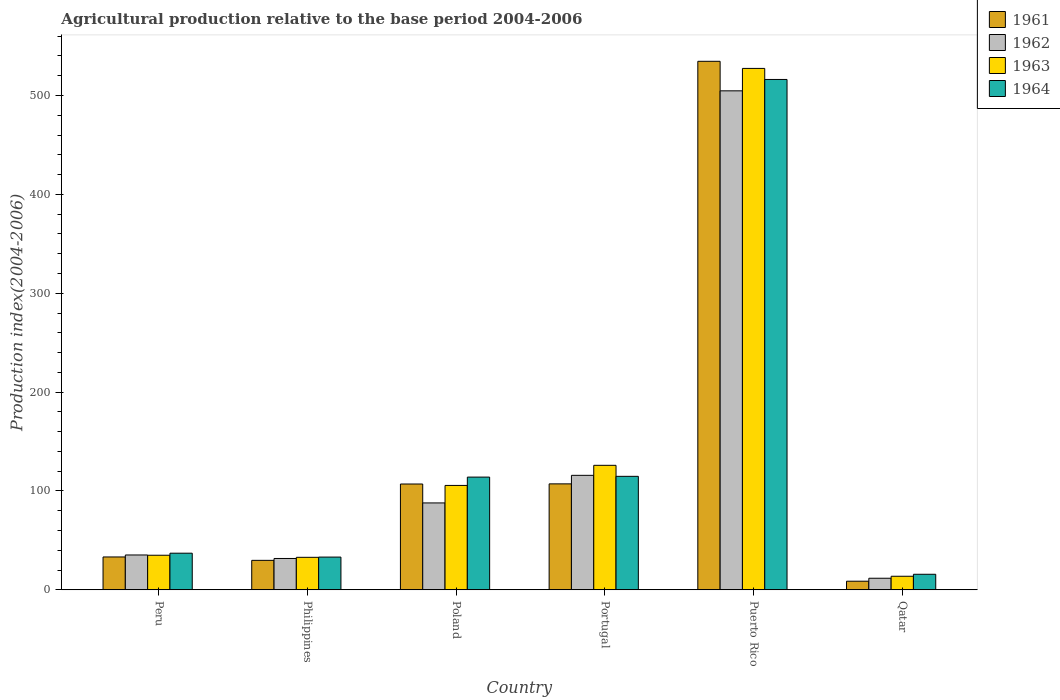How many different coloured bars are there?
Your answer should be very brief. 4. Are the number of bars per tick equal to the number of legend labels?
Offer a very short reply. Yes. Are the number of bars on each tick of the X-axis equal?
Your answer should be very brief. Yes. How many bars are there on the 3rd tick from the left?
Give a very brief answer. 4. How many bars are there on the 1st tick from the right?
Your answer should be very brief. 4. What is the label of the 4th group of bars from the left?
Offer a very short reply. Portugal. In how many cases, is the number of bars for a given country not equal to the number of legend labels?
Keep it short and to the point. 0. What is the agricultural production index in 1961 in Puerto Rico?
Your answer should be very brief. 534.58. Across all countries, what is the maximum agricultural production index in 1963?
Keep it short and to the point. 527.38. Across all countries, what is the minimum agricultural production index in 1964?
Your answer should be very brief. 15.74. In which country was the agricultural production index in 1962 maximum?
Offer a terse response. Puerto Rico. In which country was the agricultural production index in 1963 minimum?
Offer a terse response. Qatar. What is the total agricultural production index in 1962 in the graph?
Your response must be concise. 787.16. What is the difference between the agricultural production index in 1962 in Poland and that in Qatar?
Your answer should be compact. 76.17. What is the difference between the agricultural production index in 1964 in Qatar and the agricultural production index in 1963 in Peru?
Your response must be concise. -19.25. What is the average agricultural production index in 1964 per country?
Your response must be concise. 138.5. What is the difference between the agricultural production index of/in 1963 and agricultural production index of/in 1964 in Philippines?
Your answer should be compact. -0.24. In how many countries, is the agricultural production index in 1963 greater than 340?
Offer a very short reply. 1. What is the ratio of the agricultural production index in 1961 in Puerto Rico to that in Qatar?
Provide a succinct answer. 61.23. Is the agricultural production index in 1963 in Peru less than that in Puerto Rico?
Your answer should be very brief. Yes. Is the difference between the agricultural production index in 1963 in Peru and Poland greater than the difference between the agricultural production index in 1964 in Peru and Poland?
Your answer should be compact. Yes. What is the difference between the highest and the second highest agricultural production index in 1963?
Provide a succinct answer. -20.34. What is the difference between the highest and the lowest agricultural production index in 1961?
Offer a terse response. 525.85. In how many countries, is the agricultural production index in 1962 greater than the average agricultural production index in 1962 taken over all countries?
Offer a very short reply. 1. Is the sum of the agricultural production index in 1963 in Peru and Philippines greater than the maximum agricultural production index in 1964 across all countries?
Offer a very short reply. No. Is it the case that in every country, the sum of the agricultural production index in 1963 and agricultural production index in 1962 is greater than the sum of agricultural production index in 1964 and agricultural production index in 1961?
Give a very brief answer. No. What does the 3rd bar from the right in Qatar represents?
Your answer should be very brief. 1962. Is it the case that in every country, the sum of the agricultural production index in 1963 and agricultural production index in 1964 is greater than the agricultural production index in 1962?
Offer a terse response. Yes. How many bars are there?
Provide a short and direct response. 24. How many countries are there in the graph?
Provide a short and direct response. 6. Does the graph contain grids?
Provide a succinct answer. No. How many legend labels are there?
Offer a terse response. 4. What is the title of the graph?
Keep it short and to the point. Agricultural production relative to the base period 2004-2006. What is the label or title of the Y-axis?
Provide a short and direct response. Production index(2004-2006). What is the Production index(2004-2006) in 1961 in Peru?
Your answer should be compact. 33.26. What is the Production index(2004-2006) of 1962 in Peru?
Give a very brief answer. 35.27. What is the Production index(2004-2006) of 1963 in Peru?
Offer a terse response. 34.99. What is the Production index(2004-2006) in 1964 in Peru?
Offer a terse response. 37.07. What is the Production index(2004-2006) of 1961 in Philippines?
Offer a very short reply. 29.83. What is the Production index(2004-2006) in 1962 in Philippines?
Offer a terse response. 31.73. What is the Production index(2004-2006) of 1963 in Philippines?
Keep it short and to the point. 32.89. What is the Production index(2004-2006) in 1964 in Philippines?
Your response must be concise. 33.13. What is the Production index(2004-2006) in 1961 in Poland?
Ensure brevity in your answer.  107.05. What is the Production index(2004-2006) of 1962 in Poland?
Your response must be concise. 87.9. What is the Production index(2004-2006) in 1963 in Poland?
Keep it short and to the point. 105.61. What is the Production index(2004-2006) of 1964 in Poland?
Ensure brevity in your answer.  114.03. What is the Production index(2004-2006) of 1961 in Portugal?
Ensure brevity in your answer.  107.18. What is the Production index(2004-2006) of 1962 in Portugal?
Your answer should be very brief. 115.82. What is the Production index(2004-2006) of 1963 in Portugal?
Your response must be concise. 125.95. What is the Production index(2004-2006) in 1964 in Portugal?
Your response must be concise. 114.81. What is the Production index(2004-2006) in 1961 in Puerto Rico?
Keep it short and to the point. 534.58. What is the Production index(2004-2006) of 1962 in Puerto Rico?
Keep it short and to the point. 504.71. What is the Production index(2004-2006) in 1963 in Puerto Rico?
Provide a short and direct response. 527.38. What is the Production index(2004-2006) of 1964 in Puerto Rico?
Offer a very short reply. 516.21. What is the Production index(2004-2006) in 1961 in Qatar?
Ensure brevity in your answer.  8.73. What is the Production index(2004-2006) in 1962 in Qatar?
Your response must be concise. 11.73. What is the Production index(2004-2006) in 1963 in Qatar?
Your response must be concise. 13.74. What is the Production index(2004-2006) in 1964 in Qatar?
Your response must be concise. 15.74. Across all countries, what is the maximum Production index(2004-2006) in 1961?
Ensure brevity in your answer.  534.58. Across all countries, what is the maximum Production index(2004-2006) in 1962?
Provide a succinct answer. 504.71. Across all countries, what is the maximum Production index(2004-2006) in 1963?
Your answer should be compact. 527.38. Across all countries, what is the maximum Production index(2004-2006) in 1964?
Give a very brief answer. 516.21. Across all countries, what is the minimum Production index(2004-2006) of 1961?
Provide a succinct answer. 8.73. Across all countries, what is the minimum Production index(2004-2006) of 1962?
Give a very brief answer. 11.73. Across all countries, what is the minimum Production index(2004-2006) in 1963?
Your answer should be compact. 13.74. Across all countries, what is the minimum Production index(2004-2006) of 1964?
Your answer should be very brief. 15.74. What is the total Production index(2004-2006) in 1961 in the graph?
Offer a terse response. 820.63. What is the total Production index(2004-2006) in 1962 in the graph?
Offer a terse response. 787.16. What is the total Production index(2004-2006) in 1963 in the graph?
Your answer should be very brief. 840.56. What is the total Production index(2004-2006) in 1964 in the graph?
Your answer should be very brief. 830.99. What is the difference between the Production index(2004-2006) of 1961 in Peru and that in Philippines?
Keep it short and to the point. 3.43. What is the difference between the Production index(2004-2006) in 1962 in Peru and that in Philippines?
Offer a terse response. 3.54. What is the difference between the Production index(2004-2006) in 1963 in Peru and that in Philippines?
Make the answer very short. 2.1. What is the difference between the Production index(2004-2006) of 1964 in Peru and that in Philippines?
Your answer should be compact. 3.94. What is the difference between the Production index(2004-2006) of 1961 in Peru and that in Poland?
Give a very brief answer. -73.79. What is the difference between the Production index(2004-2006) in 1962 in Peru and that in Poland?
Offer a terse response. -52.63. What is the difference between the Production index(2004-2006) in 1963 in Peru and that in Poland?
Offer a very short reply. -70.62. What is the difference between the Production index(2004-2006) of 1964 in Peru and that in Poland?
Your answer should be compact. -76.96. What is the difference between the Production index(2004-2006) in 1961 in Peru and that in Portugal?
Offer a very short reply. -73.92. What is the difference between the Production index(2004-2006) in 1962 in Peru and that in Portugal?
Give a very brief answer. -80.55. What is the difference between the Production index(2004-2006) of 1963 in Peru and that in Portugal?
Provide a short and direct response. -90.96. What is the difference between the Production index(2004-2006) of 1964 in Peru and that in Portugal?
Your answer should be very brief. -77.74. What is the difference between the Production index(2004-2006) in 1961 in Peru and that in Puerto Rico?
Ensure brevity in your answer.  -501.32. What is the difference between the Production index(2004-2006) of 1962 in Peru and that in Puerto Rico?
Provide a succinct answer. -469.44. What is the difference between the Production index(2004-2006) of 1963 in Peru and that in Puerto Rico?
Your response must be concise. -492.39. What is the difference between the Production index(2004-2006) of 1964 in Peru and that in Puerto Rico?
Your response must be concise. -479.14. What is the difference between the Production index(2004-2006) in 1961 in Peru and that in Qatar?
Provide a short and direct response. 24.53. What is the difference between the Production index(2004-2006) in 1962 in Peru and that in Qatar?
Give a very brief answer. 23.54. What is the difference between the Production index(2004-2006) in 1963 in Peru and that in Qatar?
Your response must be concise. 21.25. What is the difference between the Production index(2004-2006) of 1964 in Peru and that in Qatar?
Your response must be concise. 21.33. What is the difference between the Production index(2004-2006) of 1961 in Philippines and that in Poland?
Offer a terse response. -77.22. What is the difference between the Production index(2004-2006) in 1962 in Philippines and that in Poland?
Keep it short and to the point. -56.17. What is the difference between the Production index(2004-2006) in 1963 in Philippines and that in Poland?
Keep it short and to the point. -72.72. What is the difference between the Production index(2004-2006) of 1964 in Philippines and that in Poland?
Your answer should be compact. -80.9. What is the difference between the Production index(2004-2006) of 1961 in Philippines and that in Portugal?
Give a very brief answer. -77.35. What is the difference between the Production index(2004-2006) of 1962 in Philippines and that in Portugal?
Your answer should be compact. -84.09. What is the difference between the Production index(2004-2006) of 1963 in Philippines and that in Portugal?
Your answer should be compact. -93.06. What is the difference between the Production index(2004-2006) in 1964 in Philippines and that in Portugal?
Keep it short and to the point. -81.68. What is the difference between the Production index(2004-2006) of 1961 in Philippines and that in Puerto Rico?
Provide a succinct answer. -504.75. What is the difference between the Production index(2004-2006) of 1962 in Philippines and that in Puerto Rico?
Ensure brevity in your answer.  -472.98. What is the difference between the Production index(2004-2006) in 1963 in Philippines and that in Puerto Rico?
Your answer should be very brief. -494.49. What is the difference between the Production index(2004-2006) of 1964 in Philippines and that in Puerto Rico?
Your response must be concise. -483.08. What is the difference between the Production index(2004-2006) of 1961 in Philippines and that in Qatar?
Your answer should be compact. 21.1. What is the difference between the Production index(2004-2006) of 1962 in Philippines and that in Qatar?
Give a very brief answer. 20. What is the difference between the Production index(2004-2006) of 1963 in Philippines and that in Qatar?
Your answer should be very brief. 19.15. What is the difference between the Production index(2004-2006) in 1964 in Philippines and that in Qatar?
Keep it short and to the point. 17.39. What is the difference between the Production index(2004-2006) of 1961 in Poland and that in Portugal?
Offer a terse response. -0.13. What is the difference between the Production index(2004-2006) in 1962 in Poland and that in Portugal?
Offer a very short reply. -27.92. What is the difference between the Production index(2004-2006) in 1963 in Poland and that in Portugal?
Ensure brevity in your answer.  -20.34. What is the difference between the Production index(2004-2006) of 1964 in Poland and that in Portugal?
Offer a very short reply. -0.78. What is the difference between the Production index(2004-2006) of 1961 in Poland and that in Puerto Rico?
Ensure brevity in your answer.  -427.53. What is the difference between the Production index(2004-2006) of 1962 in Poland and that in Puerto Rico?
Your response must be concise. -416.81. What is the difference between the Production index(2004-2006) in 1963 in Poland and that in Puerto Rico?
Your response must be concise. -421.77. What is the difference between the Production index(2004-2006) of 1964 in Poland and that in Puerto Rico?
Your answer should be compact. -402.18. What is the difference between the Production index(2004-2006) in 1961 in Poland and that in Qatar?
Offer a terse response. 98.32. What is the difference between the Production index(2004-2006) in 1962 in Poland and that in Qatar?
Provide a short and direct response. 76.17. What is the difference between the Production index(2004-2006) in 1963 in Poland and that in Qatar?
Offer a very short reply. 91.87. What is the difference between the Production index(2004-2006) in 1964 in Poland and that in Qatar?
Ensure brevity in your answer.  98.29. What is the difference between the Production index(2004-2006) in 1961 in Portugal and that in Puerto Rico?
Your answer should be very brief. -427.4. What is the difference between the Production index(2004-2006) in 1962 in Portugal and that in Puerto Rico?
Provide a short and direct response. -388.89. What is the difference between the Production index(2004-2006) in 1963 in Portugal and that in Puerto Rico?
Your answer should be very brief. -401.43. What is the difference between the Production index(2004-2006) of 1964 in Portugal and that in Puerto Rico?
Keep it short and to the point. -401.4. What is the difference between the Production index(2004-2006) in 1961 in Portugal and that in Qatar?
Ensure brevity in your answer.  98.45. What is the difference between the Production index(2004-2006) of 1962 in Portugal and that in Qatar?
Make the answer very short. 104.09. What is the difference between the Production index(2004-2006) of 1963 in Portugal and that in Qatar?
Your answer should be very brief. 112.21. What is the difference between the Production index(2004-2006) of 1964 in Portugal and that in Qatar?
Ensure brevity in your answer.  99.07. What is the difference between the Production index(2004-2006) in 1961 in Puerto Rico and that in Qatar?
Make the answer very short. 525.85. What is the difference between the Production index(2004-2006) in 1962 in Puerto Rico and that in Qatar?
Keep it short and to the point. 492.98. What is the difference between the Production index(2004-2006) of 1963 in Puerto Rico and that in Qatar?
Provide a short and direct response. 513.64. What is the difference between the Production index(2004-2006) of 1964 in Puerto Rico and that in Qatar?
Provide a succinct answer. 500.47. What is the difference between the Production index(2004-2006) in 1961 in Peru and the Production index(2004-2006) in 1962 in Philippines?
Give a very brief answer. 1.53. What is the difference between the Production index(2004-2006) of 1961 in Peru and the Production index(2004-2006) of 1963 in Philippines?
Make the answer very short. 0.37. What is the difference between the Production index(2004-2006) of 1961 in Peru and the Production index(2004-2006) of 1964 in Philippines?
Your response must be concise. 0.13. What is the difference between the Production index(2004-2006) of 1962 in Peru and the Production index(2004-2006) of 1963 in Philippines?
Make the answer very short. 2.38. What is the difference between the Production index(2004-2006) of 1962 in Peru and the Production index(2004-2006) of 1964 in Philippines?
Your answer should be compact. 2.14. What is the difference between the Production index(2004-2006) in 1963 in Peru and the Production index(2004-2006) in 1964 in Philippines?
Keep it short and to the point. 1.86. What is the difference between the Production index(2004-2006) of 1961 in Peru and the Production index(2004-2006) of 1962 in Poland?
Provide a short and direct response. -54.64. What is the difference between the Production index(2004-2006) of 1961 in Peru and the Production index(2004-2006) of 1963 in Poland?
Make the answer very short. -72.35. What is the difference between the Production index(2004-2006) in 1961 in Peru and the Production index(2004-2006) in 1964 in Poland?
Keep it short and to the point. -80.77. What is the difference between the Production index(2004-2006) in 1962 in Peru and the Production index(2004-2006) in 1963 in Poland?
Give a very brief answer. -70.34. What is the difference between the Production index(2004-2006) in 1962 in Peru and the Production index(2004-2006) in 1964 in Poland?
Offer a terse response. -78.76. What is the difference between the Production index(2004-2006) of 1963 in Peru and the Production index(2004-2006) of 1964 in Poland?
Give a very brief answer. -79.04. What is the difference between the Production index(2004-2006) in 1961 in Peru and the Production index(2004-2006) in 1962 in Portugal?
Make the answer very short. -82.56. What is the difference between the Production index(2004-2006) of 1961 in Peru and the Production index(2004-2006) of 1963 in Portugal?
Your response must be concise. -92.69. What is the difference between the Production index(2004-2006) in 1961 in Peru and the Production index(2004-2006) in 1964 in Portugal?
Provide a short and direct response. -81.55. What is the difference between the Production index(2004-2006) in 1962 in Peru and the Production index(2004-2006) in 1963 in Portugal?
Keep it short and to the point. -90.68. What is the difference between the Production index(2004-2006) of 1962 in Peru and the Production index(2004-2006) of 1964 in Portugal?
Your answer should be very brief. -79.54. What is the difference between the Production index(2004-2006) of 1963 in Peru and the Production index(2004-2006) of 1964 in Portugal?
Offer a terse response. -79.82. What is the difference between the Production index(2004-2006) of 1961 in Peru and the Production index(2004-2006) of 1962 in Puerto Rico?
Offer a very short reply. -471.45. What is the difference between the Production index(2004-2006) of 1961 in Peru and the Production index(2004-2006) of 1963 in Puerto Rico?
Your answer should be very brief. -494.12. What is the difference between the Production index(2004-2006) of 1961 in Peru and the Production index(2004-2006) of 1964 in Puerto Rico?
Make the answer very short. -482.95. What is the difference between the Production index(2004-2006) of 1962 in Peru and the Production index(2004-2006) of 1963 in Puerto Rico?
Keep it short and to the point. -492.11. What is the difference between the Production index(2004-2006) of 1962 in Peru and the Production index(2004-2006) of 1964 in Puerto Rico?
Your answer should be very brief. -480.94. What is the difference between the Production index(2004-2006) in 1963 in Peru and the Production index(2004-2006) in 1964 in Puerto Rico?
Give a very brief answer. -481.22. What is the difference between the Production index(2004-2006) of 1961 in Peru and the Production index(2004-2006) of 1962 in Qatar?
Your response must be concise. 21.53. What is the difference between the Production index(2004-2006) in 1961 in Peru and the Production index(2004-2006) in 1963 in Qatar?
Offer a very short reply. 19.52. What is the difference between the Production index(2004-2006) in 1961 in Peru and the Production index(2004-2006) in 1964 in Qatar?
Provide a succinct answer. 17.52. What is the difference between the Production index(2004-2006) of 1962 in Peru and the Production index(2004-2006) of 1963 in Qatar?
Your response must be concise. 21.53. What is the difference between the Production index(2004-2006) in 1962 in Peru and the Production index(2004-2006) in 1964 in Qatar?
Provide a short and direct response. 19.53. What is the difference between the Production index(2004-2006) in 1963 in Peru and the Production index(2004-2006) in 1964 in Qatar?
Ensure brevity in your answer.  19.25. What is the difference between the Production index(2004-2006) of 1961 in Philippines and the Production index(2004-2006) of 1962 in Poland?
Offer a terse response. -58.07. What is the difference between the Production index(2004-2006) of 1961 in Philippines and the Production index(2004-2006) of 1963 in Poland?
Offer a terse response. -75.78. What is the difference between the Production index(2004-2006) of 1961 in Philippines and the Production index(2004-2006) of 1964 in Poland?
Provide a short and direct response. -84.2. What is the difference between the Production index(2004-2006) in 1962 in Philippines and the Production index(2004-2006) in 1963 in Poland?
Make the answer very short. -73.88. What is the difference between the Production index(2004-2006) in 1962 in Philippines and the Production index(2004-2006) in 1964 in Poland?
Your response must be concise. -82.3. What is the difference between the Production index(2004-2006) of 1963 in Philippines and the Production index(2004-2006) of 1964 in Poland?
Your answer should be very brief. -81.14. What is the difference between the Production index(2004-2006) in 1961 in Philippines and the Production index(2004-2006) in 1962 in Portugal?
Provide a succinct answer. -85.99. What is the difference between the Production index(2004-2006) in 1961 in Philippines and the Production index(2004-2006) in 1963 in Portugal?
Give a very brief answer. -96.12. What is the difference between the Production index(2004-2006) in 1961 in Philippines and the Production index(2004-2006) in 1964 in Portugal?
Your answer should be very brief. -84.98. What is the difference between the Production index(2004-2006) of 1962 in Philippines and the Production index(2004-2006) of 1963 in Portugal?
Your answer should be very brief. -94.22. What is the difference between the Production index(2004-2006) in 1962 in Philippines and the Production index(2004-2006) in 1964 in Portugal?
Give a very brief answer. -83.08. What is the difference between the Production index(2004-2006) of 1963 in Philippines and the Production index(2004-2006) of 1964 in Portugal?
Your response must be concise. -81.92. What is the difference between the Production index(2004-2006) of 1961 in Philippines and the Production index(2004-2006) of 1962 in Puerto Rico?
Provide a short and direct response. -474.88. What is the difference between the Production index(2004-2006) in 1961 in Philippines and the Production index(2004-2006) in 1963 in Puerto Rico?
Offer a terse response. -497.55. What is the difference between the Production index(2004-2006) in 1961 in Philippines and the Production index(2004-2006) in 1964 in Puerto Rico?
Keep it short and to the point. -486.38. What is the difference between the Production index(2004-2006) in 1962 in Philippines and the Production index(2004-2006) in 1963 in Puerto Rico?
Your response must be concise. -495.65. What is the difference between the Production index(2004-2006) of 1962 in Philippines and the Production index(2004-2006) of 1964 in Puerto Rico?
Offer a terse response. -484.48. What is the difference between the Production index(2004-2006) in 1963 in Philippines and the Production index(2004-2006) in 1964 in Puerto Rico?
Provide a succinct answer. -483.32. What is the difference between the Production index(2004-2006) of 1961 in Philippines and the Production index(2004-2006) of 1963 in Qatar?
Provide a short and direct response. 16.09. What is the difference between the Production index(2004-2006) in 1961 in Philippines and the Production index(2004-2006) in 1964 in Qatar?
Make the answer very short. 14.09. What is the difference between the Production index(2004-2006) of 1962 in Philippines and the Production index(2004-2006) of 1963 in Qatar?
Keep it short and to the point. 17.99. What is the difference between the Production index(2004-2006) of 1962 in Philippines and the Production index(2004-2006) of 1964 in Qatar?
Keep it short and to the point. 15.99. What is the difference between the Production index(2004-2006) of 1963 in Philippines and the Production index(2004-2006) of 1964 in Qatar?
Give a very brief answer. 17.15. What is the difference between the Production index(2004-2006) in 1961 in Poland and the Production index(2004-2006) in 1962 in Portugal?
Provide a short and direct response. -8.77. What is the difference between the Production index(2004-2006) in 1961 in Poland and the Production index(2004-2006) in 1963 in Portugal?
Provide a short and direct response. -18.9. What is the difference between the Production index(2004-2006) of 1961 in Poland and the Production index(2004-2006) of 1964 in Portugal?
Your answer should be compact. -7.76. What is the difference between the Production index(2004-2006) of 1962 in Poland and the Production index(2004-2006) of 1963 in Portugal?
Provide a short and direct response. -38.05. What is the difference between the Production index(2004-2006) of 1962 in Poland and the Production index(2004-2006) of 1964 in Portugal?
Your answer should be compact. -26.91. What is the difference between the Production index(2004-2006) in 1963 in Poland and the Production index(2004-2006) in 1964 in Portugal?
Offer a terse response. -9.2. What is the difference between the Production index(2004-2006) in 1961 in Poland and the Production index(2004-2006) in 1962 in Puerto Rico?
Your answer should be very brief. -397.66. What is the difference between the Production index(2004-2006) of 1961 in Poland and the Production index(2004-2006) of 1963 in Puerto Rico?
Keep it short and to the point. -420.33. What is the difference between the Production index(2004-2006) in 1961 in Poland and the Production index(2004-2006) in 1964 in Puerto Rico?
Offer a very short reply. -409.16. What is the difference between the Production index(2004-2006) of 1962 in Poland and the Production index(2004-2006) of 1963 in Puerto Rico?
Your answer should be very brief. -439.48. What is the difference between the Production index(2004-2006) of 1962 in Poland and the Production index(2004-2006) of 1964 in Puerto Rico?
Offer a terse response. -428.31. What is the difference between the Production index(2004-2006) of 1963 in Poland and the Production index(2004-2006) of 1964 in Puerto Rico?
Provide a short and direct response. -410.6. What is the difference between the Production index(2004-2006) of 1961 in Poland and the Production index(2004-2006) of 1962 in Qatar?
Your answer should be very brief. 95.32. What is the difference between the Production index(2004-2006) of 1961 in Poland and the Production index(2004-2006) of 1963 in Qatar?
Make the answer very short. 93.31. What is the difference between the Production index(2004-2006) in 1961 in Poland and the Production index(2004-2006) in 1964 in Qatar?
Your response must be concise. 91.31. What is the difference between the Production index(2004-2006) of 1962 in Poland and the Production index(2004-2006) of 1963 in Qatar?
Your answer should be compact. 74.16. What is the difference between the Production index(2004-2006) in 1962 in Poland and the Production index(2004-2006) in 1964 in Qatar?
Keep it short and to the point. 72.16. What is the difference between the Production index(2004-2006) of 1963 in Poland and the Production index(2004-2006) of 1964 in Qatar?
Make the answer very short. 89.87. What is the difference between the Production index(2004-2006) in 1961 in Portugal and the Production index(2004-2006) in 1962 in Puerto Rico?
Offer a terse response. -397.53. What is the difference between the Production index(2004-2006) of 1961 in Portugal and the Production index(2004-2006) of 1963 in Puerto Rico?
Make the answer very short. -420.2. What is the difference between the Production index(2004-2006) of 1961 in Portugal and the Production index(2004-2006) of 1964 in Puerto Rico?
Your answer should be very brief. -409.03. What is the difference between the Production index(2004-2006) of 1962 in Portugal and the Production index(2004-2006) of 1963 in Puerto Rico?
Give a very brief answer. -411.56. What is the difference between the Production index(2004-2006) in 1962 in Portugal and the Production index(2004-2006) in 1964 in Puerto Rico?
Keep it short and to the point. -400.39. What is the difference between the Production index(2004-2006) of 1963 in Portugal and the Production index(2004-2006) of 1964 in Puerto Rico?
Give a very brief answer. -390.26. What is the difference between the Production index(2004-2006) of 1961 in Portugal and the Production index(2004-2006) of 1962 in Qatar?
Keep it short and to the point. 95.45. What is the difference between the Production index(2004-2006) in 1961 in Portugal and the Production index(2004-2006) in 1963 in Qatar?
Offer a very short reply. 93.44. What is the difference between the Production index(2004-2006) of 1961 in Portugal and the Production index(2004-2006) of 1964 in Qatar?
Your answer should be very brief. 91.44. What is the difference between the Production index(2004-2006) of 1962 in Portugal and the Production index(2004-2006) of 1963 in Qatar?
Provide a short and direct response. 102.08. What is the difference between the Production index(2004-2006) in 1962 in Portugal and the Production index(2004-2006) in 1964 in Qatar?
Give a very brief answer. 100.08. What is the difference between the Production index(2004-2006) in 1963 in Portugal and the Production index(2004-2006) in 1964 in Qatar?
Your response must be concise. 110.21. What is the difference between the Production index(2004-2006) in 1961 in Puerto Rico and the Production index(2004-2006) in 1962 in Qatar?
Make the answer very short. 522.85. What is the difference between the Production index(2004-2006) of 1961 in Puerto Rico and the Production index(2004-2006) of 1963 in Qatar?
Give a very brief answer. 520.84. What is the difference between the Production index(2004-2006) of 1961 in Puerto Rico and the Production index(2004-2006) of 1964 in Qatar?
Your answer should be compact. 518.84. What is the difference between the Production index(2004-2006) of 1962 in Puerto Rico and the Production index(2004-2006) of 1963 in Qatar?
Give a very brief answer. 490.97. What is the difference between the Production index(2004-2006) of 1962 in Puerto Rico and the Production index(2004-2006) of 1964 in Qatar?
Your response must be concise. 488.97. What is the difference between the Production index(2004-2006) of 1963 in Puerto Rico and the Production index(2004-2006) of 1964 in Qatar?
Your response must be concise. 511.64. What is the average Production index(2004-2006) in 1961 per country?
Your answer should be very brief. 136.77. What is the average Production index(2004-2006) in 1962 per country?
Provide a short and direct response. 131.19. What is the average Production index(2004-2006) of 1963 per country?
Make the answer very short. 140.09. What is the average Production index(2004-2006) of 1964 per country?
Ensure brevity in your answer.  138.5. What is the difference between the Production index(2004-2006) of 1961 and Production index(2004-2006) of 1962 in Peru?
Your response must be concise. -2.01. What is the difference between the Production index(2004-2006) in 1961 and Production index(2004-2006) in 1963 in Peru?
Ensure brevity in your answer.  -1.73. What is the difference between the Production index(2004-2006) of 1961 and Production index(2004-2006) of 1964 in Peru?
Ensure brevity in your answer.  -3.81. What is the difference between the Production index(2004-2006) in 1962 and Production index(2004-2006) in 1963 in Peru?
Your answer should be compact. 0.28. What is the difference between the Production index(2004-2006) in 1963 and Production index(2004-2006) in 1964 in Peru?
Keep it short and to the point. -2.08. What is the difference between the Production index(2004-2006) in 1961 and Production index(2004-2006) in 1963 in Philippines?
Your response must be concise. -3.06. What is the difference between the Production index(2004-2006) in 1962 and Production index(2004-2006) in 1963 in Philippines?
Provide a short and direct response. -1.16. What is the difference between the Production index(2004-2006) in 1962 and Production index(2004-2006) in 1964 in Philippines?
Provide a succinct answer. -1.4. What is the difference between the Production index(2004-2006) in 1963 and Production index(2004-2006) in 1964 in Philippines?
Offer a terse response. -0.24. What is the difference between the Production index(2004-2006) in 1961 and Production index(2004-2006) in 1962 in Poland?
Your answer should be very brief. 19.15. What is the difference between the Production index(2004-2006) of 1961 and Production index(2004-2006) of 1963 in Poland?
Make the answer very short. 1.44. What is the difference between the Production index(2004-2006) of 1961 and Production index(2004-2006) of 1964 in Poland?
Ensure brevity in your answer.  -6.98. What is the difference between the Production index(2004-2006) in 1962 and Production index(2004-2006) in 1963 in Poland?
Offer a terse response. -17.71. What is the difference between the Production index(2004-2006) in 1962 and Production index(2004-2006) in 1964 in Poland?
Your answer should be very brief. -26.13. What is the difference between the Production index(2004-2006) of 1963 and Production index(2004-2006) of 1964 in Poland?
Make the answer very short. -8.42. What is the difference between the Production index(2004-2006) of 1961 and Production index(2004-2006) of 1962 in Portugal?
Your answer should be very brief. -8.64. What is the difference between the Production index(2004-2006) of 1961 and Production index(2004-2006) of 1963 in Portugal?
Keep it short and to the point. -18.77. What is the difference between the Production index(2004-2006) in 1961 and Production index(2004-2006) in 1964 in Portugal?
Your answer should be very brief. -7.63. What is the difference between the Production index(2004-2006) in 1962 and Production index(2004-2006) in 1963 in Portugal?
Your answer should be very brief. -10.13. What is the difference between the Production index(2004-2006) in 1962 and Production index(2004-2006) in 1964 in Portugal?
Offer a terse response. 1.01. What is the difference between the Production index(2004-2006) in 1963 and Production index(2004-2006) in 1964 in Portugal?
Your response must be concise. 11.14. What is the difference between the Production index(2004-2006) in 1961 and Production index(2004-2006) in 1962 in Puerto Rico?
Your answer should be very brief. 29.87. What is the difference between the Production index(2004-2006) of 1961 and Production index(2004-2006) of 1963 in Puerto Rico?
Provide a succinct answer. 7.2. What is the difference between the Production index(2004-2006) in 1961 and Production index(2004-2006) in 1964 in Puerto Rico?
Your answer should be very brief. 18.37. What is the difference between the Production index(2004-2006) of 1962 and Production index(2004-2006) of 1963 in Puerto Rico?
Give a very brief answer. -22.67. What is the difference between the Production index(2004-2006) of 1962 and Production index(2004-2006) of 1964 in Puerto Rico?
Your response must be concise. -11.5. What is the difference between the Production index(2004-2006) of 1963 and Production index(2004-2006) of 1964 in Puerto Rico?
Provide a short and direct response. 11.17. What is the difference between the Production index(2004-2006) in 1961 and Production index(2004-2006) in 1963 in Qatar?
Ensure brevity in your answer.  -5.01. What is the difference between the Production index(2004-2006) in 1961 and Production index(2004-2006) in 1964 in Qatar?
Give a very brief answer. -7.01. What is the difference between the Production index(2004-2006) of 1962 and Production index(2004-2006) of 1963 in Qatar?
Your answer should be compact. -2.01. What is the difference between the Production index(2004-2006) in 1962 and Production index(2004-2006) in 1964 in Qatar?
Keep it short and to the point. -4.01. What is the ratio of the Production index(2004-2006) of 1961 in Peru to that in Philippines?
Your answer should be compact. 1.11. What is the ratio of the Production index(2004-2006) of 1962 in Peru to that in Philippines?
Provide a succinct answer. 1.11. What is the ratio of the Production index(2004-2006) of 1963 in Peru to that in Philippines?
Ensure brevity in your answer.  1.06. What is the ratio of the Production index(2004-2006) in 1964 in Peru to that in Philippines?
Your answer should be compact. 1.12. What is the ratio of the Production index(2004-2006) in 1961 in Peru to that in Poland?
Offer a very short reply. 0.31. What is the ratio of the Production index(2004-2006) in 1962 in Peru to that in Poland?
Provide a short and direct response. 0.4. What is the ratio of the Production index(2004-2006) of 1963 in Peru to that in Poland?
Ensure brevity in your answer.  0.33. What is the ratio of the Production index(2004-2006) in 1964 in Peru to that in Poland?
Ensure brevity in your answer.  0.33. What is the ratio of the Production index(2004-2006) of 1961 in Peru to that in Portugal?
Give a very brief answer. 0.31. What is the ratio of the Production index(2004-2006) of 1962 in Peru to that in Portugal?
Your answer should be very brief. 0.3. What is the ratio of the Production index(2004-2006) in 1963 in Peru to that in Portugal?
Give a very brief answer. 0.28. What is the ratio of the Production index(2004-2006) in 1964 in Peru to that in Portugal?
Ensure brevity in your answer.  0.32. What is the ratio of the Production index(2004-2006) in 1961 in Peru to that in Puerto Rico?
Your response must be concise. 0.06. What is the ratio of the Production index(2004-2006) in 1962 in Peru to that in Puerto Rico?
Keep it short and to the point. 0.07. What is the ratio of the Production index(2004-2006) in 1963 in Peru to that in Puerto Rico?
Your answer should be compact. 0.07. What is the ratio of the Production index(2004-2006) of 1964 in Peru to that in Puerto Rico?
Make the answer very short. 0.07. What is the ratio of the Production index(2004-2006) in 1961 in Peru to that in Qatar?
Your response must be concise. 3.81. What is the ratio of the Production index(2004-2006) of 1962 in Peru to that in Qatar?
Provide a succinct answer. 3.01. What is the ratio of the Production index(2004-2006) of 1963 in Peru to that in Qatar?
Provide a succinct answer. 2.55. What is the ratio of the Production index(2004-2006) of 1964 in Peru to that in Qatar?
Keep it short and to the point. 2.36. What is the ratio of the Production index(2004-2006) of 1961 in Philippines to that in Poland?
Give a very brief answer. 0.28. What is the ratio of the Production index(2004-2006) of 1962 in Philippines to that in Poland?
Ensure brevity in your answer.  0.36. What is the ratio of the Production index(2004-2006) in 1963 in Philippines to that in Poland?
Make the answer very short. 0.31. What is the ratio of the Production index(2004-2006) in 1964 in Philippines to that in Poland?
Keep it short and to the point. 0.29. What is the ratio of the Production index(2004-2006) of 1961 in Philippines to that in Portugal?
Make the answer very short. 0.28. What is the ratio of the Production index(2004-2006) in 1962 in Philippines to that in Portugal?
Offer a terse response. 0.27. What is the ratio of the Production index(2004-2006) of 1963 in Philippines to that in Portugal?
Provide a short and direct response. 0.26. What is the ratio of the Production index(2004-2006) in 1964 in Philippines to that in Portugal?
Keep it short and to the point. 0.29. What is the ratio of the Production index(2004-2006) in 1961 in Philippines to that in Puerto Rico?
Offer a terse response. 0.06. What is the ratio of the Production index(2004-2006) of 1962 in Philippines to that in Puerto Rico?
Provide a short and direct response. 0.06. What is the ratio of the Production index(2004-2006) of 1963 in Philippines to that in Puerto Rico?
Provide a succinct answer. 0.06. What is the ratio of the Production index(2004-2006) in 1964 in Philippines to that in Puerto Rico?
Give a very brief answer. 0.06. What is the ratio of the Production index(2004-2006) in 1961 in Philippines to that in Qatar?
Offer a terse response. 3.42. What is the ratio of the Production index(2004-2006) of 1962 in Philippines to that in Qatar?
Your answer should be compact. 2.71. What is the ratio of the Production index(2004-2006) in 1963 in Philippines to that in Qatar?
Give a very brief answer. 2.39. What is the ratio of the Production index(2004-2006) of 1964 in Philippines to that in Qatar?
Provide a succinct answer. 2.1. What is the ratio of the Production index(2004-2006) of 1961 in Poland to that in Portugal?
Ensure brevity in your answer.  1. What is the ratio of the Production index(2004-2006) in 1962 in Poland to that in Portugal?
Your answer should be compact. 0.76. What is the ratio of the Production index(2004-2006) in 1963 in Poland to that in Portugal?
Your answer should be very brief. 0.84. What is the ratio of the Production index(2004-2006) in 1964 in Poland to that in Portugal?
Provide a short and direct response. 0.99. What is the ratio of the Production index(2004-2006) in 1961 in Poland to that in Puerto Rico?
Give a very brief answer. 0.2. What is the ratio of the Production index(2004-2006) in 1962 in Poland to that in Puerto Rico?
Give a very brief answer. 0.17. What is the ratio of the Production index(2004-2006) of 1963 in Poland to that in Puerto Rico?
Offer a very short reply. 0.2. What is the ratio of the Production index(2004-2006) in 1964 in Poland to that in Puerto Rico?
Provide a succinct answer. 0.22. What is the ratio of the Production index(2004-2006) of 1961 in Poland to that in Qatar?
Your response must be concise. 12.26. What is the ratio of the Production index(2004-2006) in 1962 in Poland to that in Qatar?
Your answer should be compact. 7.49. What is the ratio of the Production index(2004-2006) of 1963 in Poland to that in Qatar?
Make the answer very short. 7.69. What is the ratio of the Production index(2004-2006) in 1964 in Poland to that in Qatar?
Give a very brief answer. 7.24. What is the ratio of the Production index(2004-2006) of 1961 in Portugal to that in Puerto Rico?
Your response must be concise. 0.2. What is the ratio of the Production index(2004-2006) of 1962 in Portugal to that in Puerto Rico?
Provide a succinct answer. 0.23. What is the ratio of the Production index(2004-2006) in 1963 in Portugal to that in Puerto Rico?
Give a very brief answer. 0.24. What is the ratio of the Production index(2004-2006) of 1964 in Portugal to that in Puerto Rico?
Your answer should be compact. 0.22. What is the ratio of the Production index(2004-2006) of 1961 in Portugal to that in Qatar?
Offer a terse response. 12.28. What is the ratio of the Production index(2004-2006) of 1962 in Portugal to that in Qatar?
Keep it short and to the point. 9.87. What is the ratio of the Production index(2004-2006) of 1963 in Portugal to that in Qatar?
Your answer should be compact. 9.17. What is the ratio of the Production index(2004-2006) in 1964 in Portugal to that in Qatar?
Ensure brevity in your answer.  7.29. What is the ratio of the Production index(2004-2006) of 1961 in Puerto Rico to that in Qatar?
Provide a short and direct response. 61.23. What is the ratio of the Production index(2004-2006) in 1962 in Puerto Rico to that in Qatar?
Provide a succinct answer. 43.03. What is the ratio of the Production index(2004-2006) of 1963 in Puerto Rico to that in Qatar?
Your response must be concise. 38.38. What is the ratio of the Production index(2004-2006) of 1964 in Puerto Rico to that in Qatar?
Your response must be concise. 32.8. What is the difference between the highest and the second highest Production index(2004-2006) in 1961?
Your response must be concise. 427.4. What is the difference between the highest and the second highest Production index(2004-2006) of 1962?
Offer a very short reply. 388.89. What is the difference between the highest and the second highest Production index(2004-2006) of 1963?
Offer a very short reply. 401.43. What is the difference between the highest and the second highest Production index(2004-2006) in 1964?
Ensure brevity in your answer.  401.4. What is the difference between the highest and the lowest Production index(2004-2006) of 1961?
Your answer should be compact. 525.85. What is the difference between the highest and the lowest Production index(2004-2006) in 1962?
Offer a very short reply. 492.98. What is the difference between the highest and the lowest Production index(2004-2006) in 1963?
Your answer should be very brief. 513.64. What is the difference between the highest and the lowest Production index(2004-2006) in 1964?
Provide a short and direct response. 500.47. 